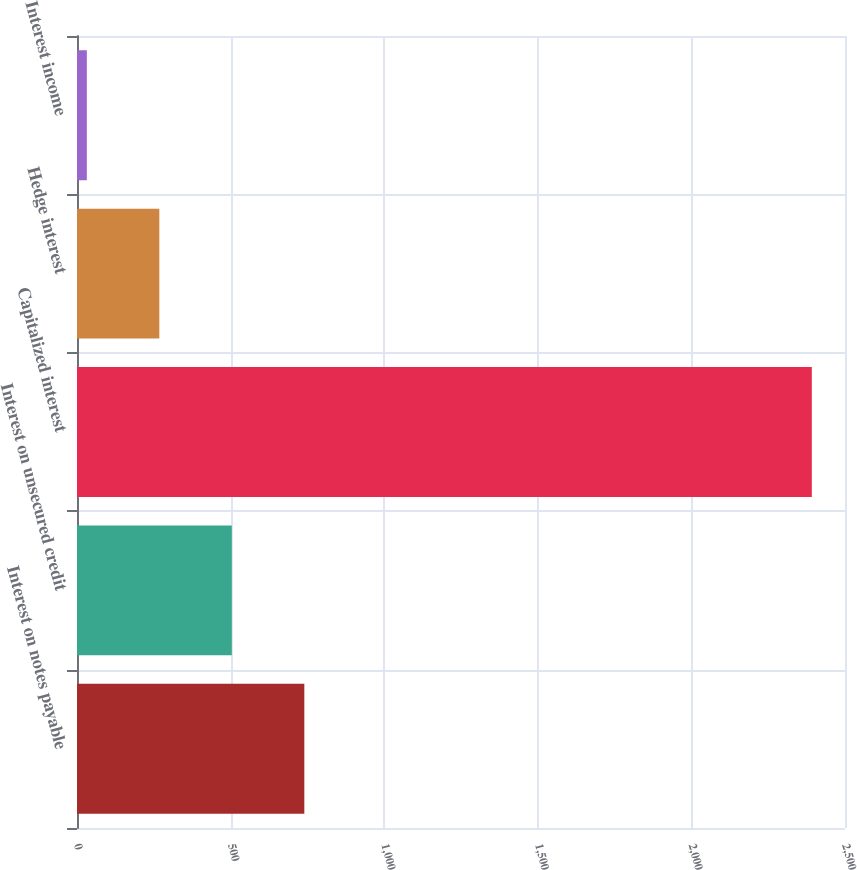Convert chart. <chart><loc_0><loc_0><loc_500><loc_500><bar_chart><fcel>Interest on notes payable<fcel>Interest on unsecured credit<fcel>Capitalized interest<fcel>Hedge interest<fcel>Interest income<nl><fcel>740<fcel>504<fcel>2392<fcel>268<fcel>32<nl></chart> 